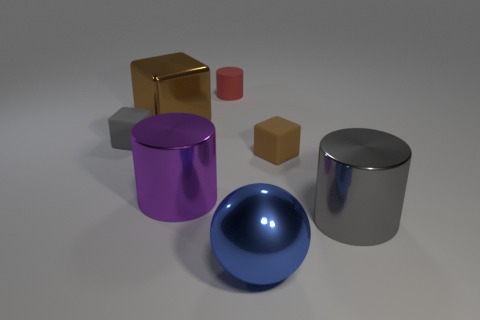How many brown cubes must be subtracted to get 1 brown cubes? 1 Add 2 small red things. How many objects exist? 9 Subtract 0 red balls. How many objects are left? 7 Subtract all cylinders. How many objects are left? 4 Subtract 2 blocks. How many blocks are left? 1 Subtract all red cylinders. Subtract all green balls. How many cylinders are left? 2 Subtract all purple blocks. How many cyan spheres are left? 0 Subtract all purple objects. Subtract all gray rubber things. How many objects are left? 5 Add 5 shiny balls. How many shiny balls are left? 6 Add 6 small green metal objects. How many small green metal objects exist? 6 